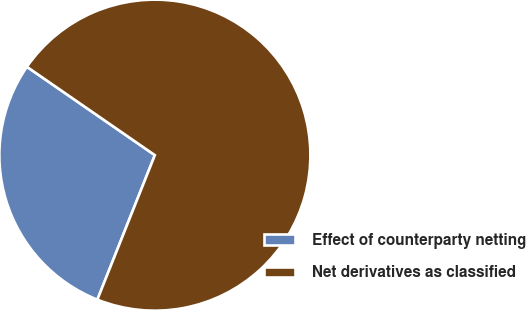Convert chart to OTSL. <chart><loc_0><loc_0><loc_500><loc_500><pie_chart><fcel>Effect of counterparty netting<fcel>Net derivatives as classified<nl><fcel>28.59%<fcel>71.41%<nl></chart> 